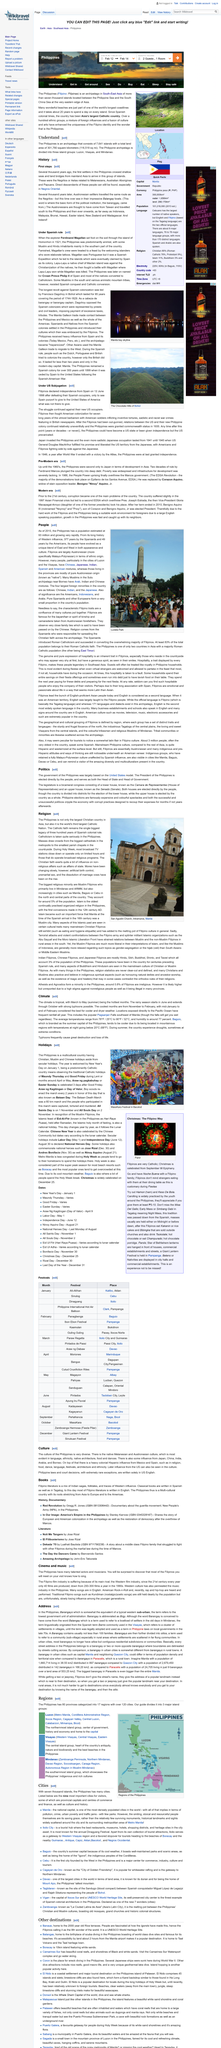Specify some key components in this picture. During Holy Week in the Philippines, most broadcast TV stations close down or operate limited hours, and those that do operate only broadcast religious programs, as opposed to regular programming. The Philippines is the world's third largest Catholic nation. The Philippines is the largest Christian country in Asia, and it is the largest Christian country in Asia. 